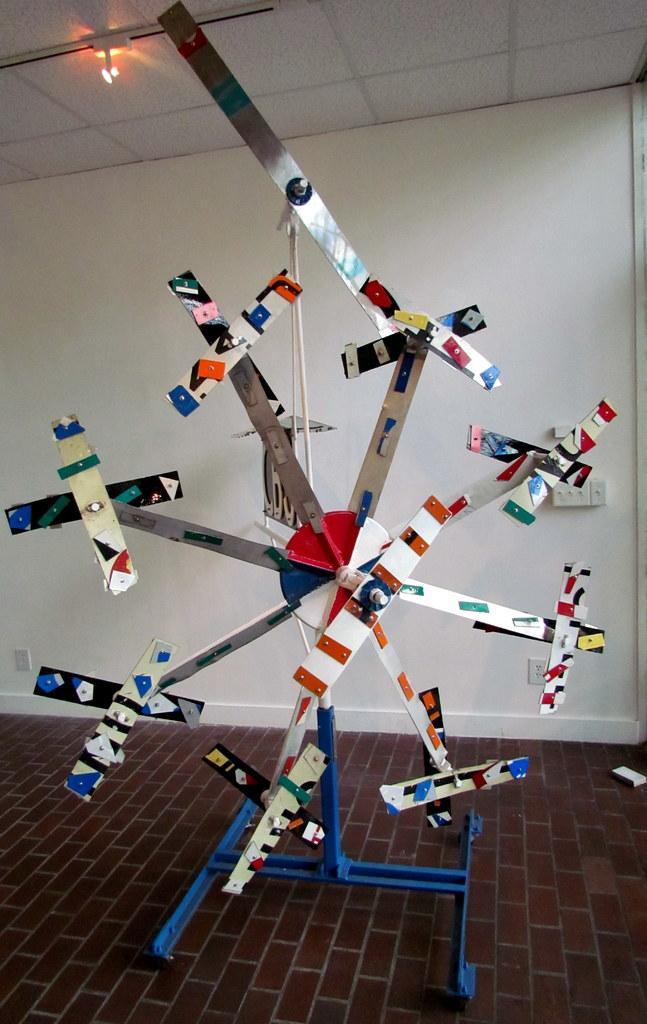Please provide a concise description of this image. In the center of the image we can see a some object. In the background of the image there is wall. At the top of the image there is ceiling with light. At the bottom of the image there is floor. 